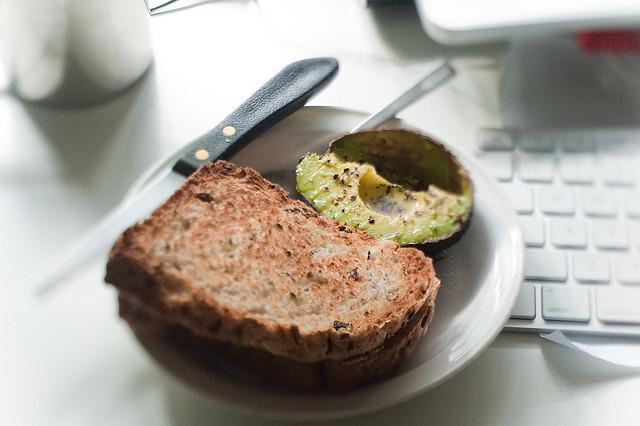What is under the plate?
Concise answer only. Keyboard. Is the avocado in its skin?
Short answer required. Yes. What is the vegetable called?
Short answer required. Avocado. 